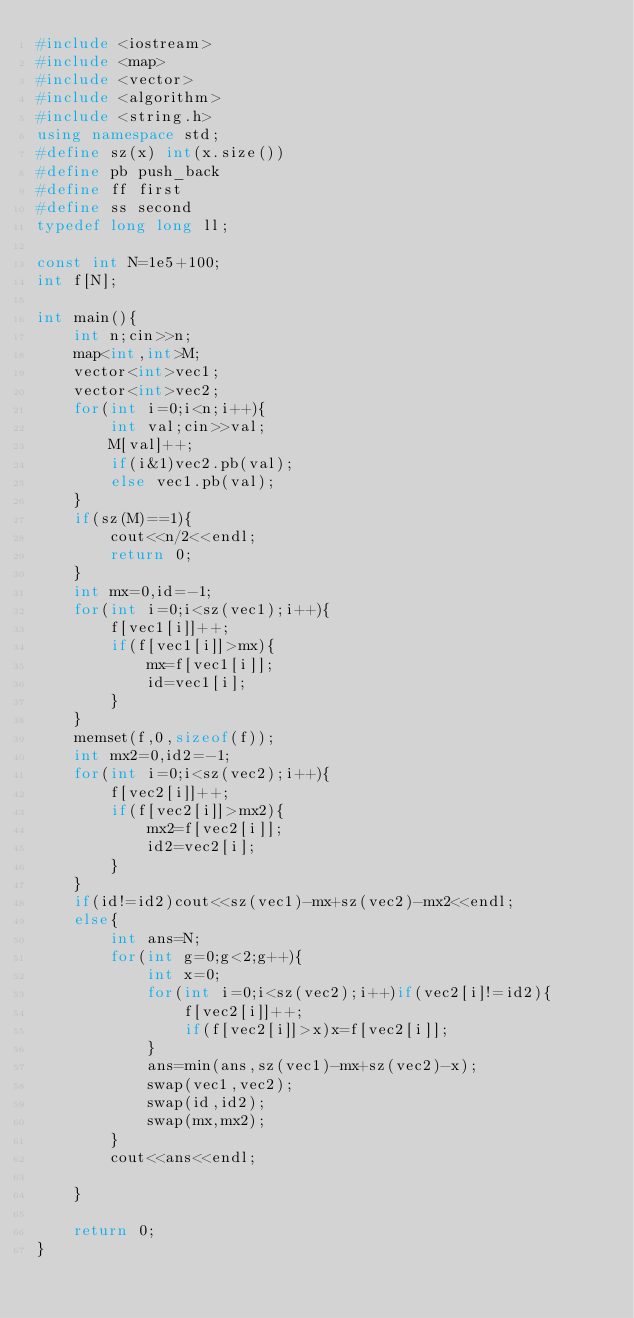<code> <loc_0><loc_0><loc_500><loc_500><_C++_>#include <iostream>
#include <map>
#include <vector>
#include <algorithm>
#include <string.h>
using namespace std;
#define sz(x) int(x.size())
#define pb push_back
#define ff first
#define ss second
typedef long long ll;

const int N=1e5+100;
int f[N];

int main(){
	int n;cin>>n;
	map<int,int>M;
	vector<int>vec1;
	vector<int>vec2;
	for(int i=0;i<n;i++){
		int val;cin>>val;
		M[val]++;
		if(i&1)vec2.pb(val);
		else vec1.pb(val);
	}
	if(sz(M)==1){
		cout<<n/2<<endl;
		return 0;
	}
	int mx=0,id=-1;
	for(int i=0;i<sz(vec1);i++){
		f[vec1[i]]++;
		if(f[vec1[i]]>mx){
			mx=f[vec1[i]];
			id=vec1[i];
		}
	}
	memset(f,0,sizeof(f));
	int mx2=0,id2=-1;
	for(int i=0;i<sz(vec2);i++){
		f[vec2[i]]++;
		if(f[vec2[i]]>mx2){
			mx2=f[vec2[i]];
			id2=vec2[i];
		}
	}
	if(id!=id2)cout<<sz(vec1)-mx+sz(vec2)-mx2<<endl;
	else{
		int ans=N;
		for(int g=0;g<2;g++){
			int x=0;
			for(int i=0;i<sz(vec2);i++)if(vec2[i]!=id2){
				f[vec2[i]]++;
				if(f[vec2[i]]>x)x=f[vec2[i]];
			}
			ans=min(ans,sz(vec1)-mx+sz(vec2)-x);
			swap(vec1,vec2);
			swap(id,id2);
			swap(mx,mx2);
		}
		cout<<ans<<endl;

	}
	
	return 0;
}
</code> 